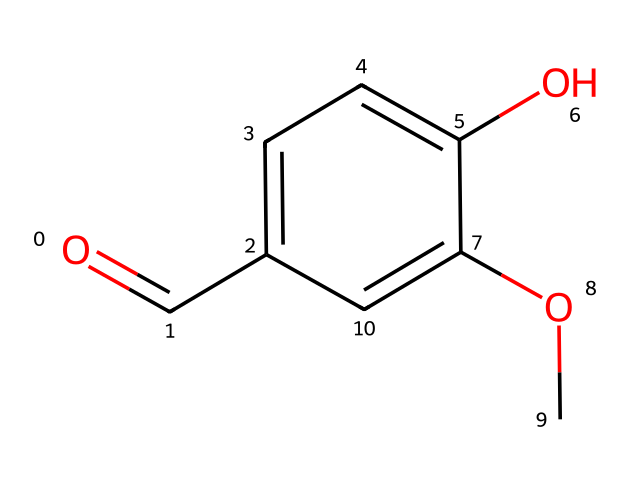how many carbon atoms are in this molecule? Analyzing the SMILES representation, we can count the number of carbon atoms present. The structure has six carbon atoms visible in the aromatic ring and one carbon atom from the aldehyde group (O=C), totaling seven carbon atoms.
Answer: seven what is the functional group present in this compound? By examining the SMILES structure, the aldehyde group is identified by the carbon atom double bonded to the oxygen (O=C) and a hydrogen atom, indicating it is an aldehyde.
Answer: aldehyde which group contributes to its sweet aroma? The methoxy group (-OCH3) attached to the aromatic ring is responsible for the sweet aroma characteristic of vanillin, making it a significant contributor to its fragrance properties.
Answer: methoxy how many oxygen atoms are there in this molecule? From the SMILES representation, we can see there are two oxygen atoms: one in the aldehyde functional group and the other in the methoxy group, giving a total of two oxygen atoms.
Answer: two what type of chemical is vanillin classified as? Vanillin, based on its structure, is classified as an aromatic aldehyde, which is a specific type of aromatic compound containing an aldehyde functional group.
Answer: aromatic aldehyde what type of isomerism does this compound exhibit? The structure shows the presence of an aromatic ring and an aldehyde group which suggests that it could exhibit geometric isomerism or positional isomerism, but mainly it has characteristics of structural isomerism among other aldehydes due to its unique arrangement of atoms.
Answer: structural isomerism which part of the molecule gives vanillin its flavoring properties? The combination of the aldehyde group and the methoxy group is crucial since both groups are typically associated with sweet flavors, making them essential in conferring the flavoring properties of vanillin.
Answer: aldehyde and methoxy groups 